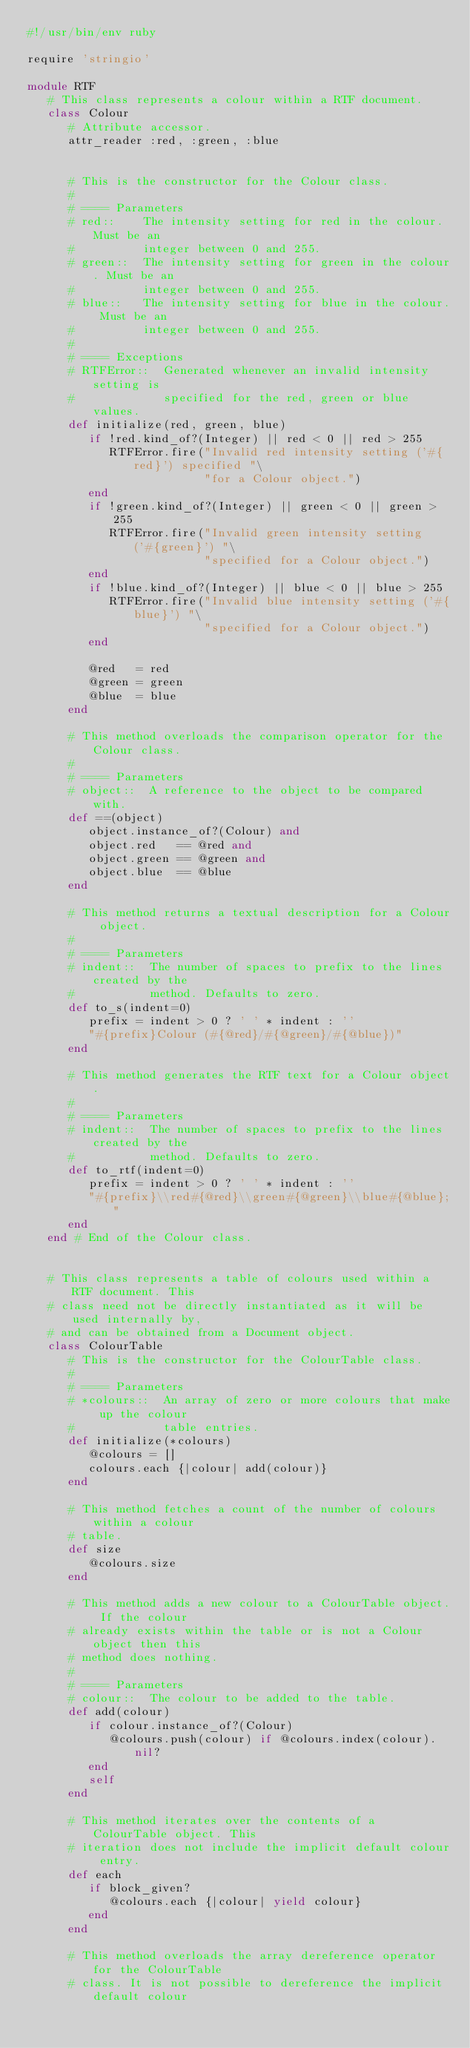Convert code to text. <code><loc_0><loc_0><loc_500><loc_500><_Ruby_>#!/usr/bin/env ruby

require 'stringio'

module RTF
   # This class represents a colour within a RTF document.
   class Colour
      # Attribute accessor.
      attr_reader :red, :green, :blue


      # This is the constructor for the Colour class.
      #
      # ==== Parameters
      # red::    The intensity setting for red in the colour. Must be an
      #          integer between 0 and 255.
      # green::  The intensity setting for green in the colour. Must be an
      #          integer between 0 and 255.
      # blue::   The intensity setting for blue in the colour. Must be an
      #          integer between 0 and 255.
      #
      # ==== Exceptions
      # RTFError::  Generated whenever an invalid intensity setting is
      #             specified for the red, green or blue values.
      def initialize(red, green, blue)
         if !red.kind_of?(Integer) || red < 0 || red > 255
            RTFError.fire("Invalid red intensity setting ('#{red}') specified "\
                          "for a Colour object.")
         end
         if !green.kind_of?(Integer) || green < 0 || green > 255
            RTFError.fire("Invalid green intensity setting ('#{green}') "\
                          "specified for a Colour object.")
         end
         if !blue.kind_of?(Integer) || blue < 0 || blue > 255
            RTFError.fire("Invalid blue intensity setting ('#{blue}') "\
                          "specified for a Colour object.")
         end

         @red   = red
         @green = green
         @blue  = blue
      end

      # This method overloads the comparison operator for the Colour class.
      #
      # ==== Parameters
      # object::  A reference to the object to be compared with.
      def ==(object)
         object.instance_of?(Colour) and
         object.red   == @red and
         object.green == @green and
         object.blue  == @blue
      end

      # This method returns a textual description for a Colour object.
      #
      # ==== Parameters
      # indent::  The number of spaces to prefix to the lines created by the
      #           method. Defaults to zero.
      def to_s(indent=0)
         prefix = indent > 0 ? ' ' * indent : ''
         "#{prefix}Colour (#{@red}/#{@green}/#{@blue})"
      end

      # This method generates the RTF text for a Colour object.
      #
      # ==== Parameters
      # indent::  The number of spaces to prefix to the lines created by the
      #           method. Defaults to zero.
      def to_rtf(indent=0)
         prefix = indent > 0 ? ' ' * indent : ''
         "#{prefix}\\red#{@red}\\green#{@green}\\blue#{@blue};"
      end
   end # End of the Colour class.


   # This class represents a table of colours used within a RTF document. This
   # class need not be directly instantiated as it will be used internally by,
   # and can be obtained from a Document object.
   class ColourTable
      # This is the constructor for the ColourTable class.
      #
      # ==== Parameters
      # *colours::  An array of zero or more colours that make up the colour
      #             table entries.
      def initialize(*colours)
         @colours = []
         colours.each {|colour| add(colour)}
      end

      # This method fetches a count of the number of colours within a colour
      # table.
      def size
         @colours.size
      end

      # This method adds a new colour to a ColourTable object. If the colour
      # already exists within the table or is not a Colour object then this
      # method does nothing.
      #
      # ==== Parameters
      # colour::  The colour to be added to the table.
      def add(colour)
         if colour.instance_of?(Colour)
            @colours.push(colour) if @colours.index(colour).nil?
         end
         self
      end

      # This method iterates over the contents of a ColourTable object. This
      # iteration does not include the implicit default colour entry.
      def each
         if block_given?
            @colours.each {|colour| yield colour}
         end
      end

      # This method overloads the array dereference operator for the ColourTable
      # class. It is not possible to dereference the implicit default colour</code> 